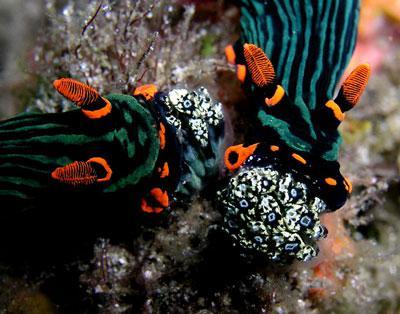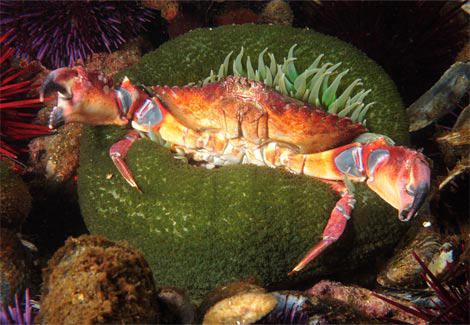The first image is the image on the left, the second image is the image on the right. Analyze the images presented: Is the assertion "One image shows the reddish-orange tinged front claws of a crustacean emerging from something with green tendrils." valid? Answer yes or no. Yes. The first image is the image on the left, the second image is the image on the right. For the images shown, is this caption "At least one clown fish is nestled among the sea anemones." true? Answer yes or no. No. 